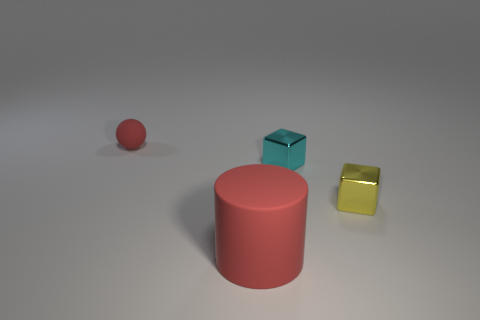Does the yellow object have the same shape as the small red thing?
Provide a succinct answer. No. Are there fewer yellow blocks that are in front of the small yellow block than big cylinders?
Keep it short and to the point. Yes. What is the color of the rubber object on the right side of the small red rubber ball that is behind the red rubber thing in front of the yellow metallic object?
Your answer should be very brief. Red. How many rubber things are either small blue blocks or small yellow things?
Keep it short and to the point. 0. Is the rubber cylinder the same size as the cyan metallic cube?
Your answer should be compact. No. Are there fewer cubes that are behind the sphere than cyan shiny things that are in front of the cylinder?
Offer a terse response. No. Are there any other things that have the same size as the yellow metallic object?
Make the answer very short. Yes. The yellow metallic block is what size?
Give a very brief answer. Small. What number of small things are cyan metallic cubes or gray rubber objects?
Provide a succinct answer. 1. Is the size of the yellow metal object the same as the red matte object that is behind the big object?
Provide a succinct answer. Yes. 